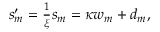Convert formula to latex. <formula><loc_0><loc_0><loc_500><loc_500>\begin{array} { r } { s _ { m } ^ { \prime } = \frac { 1 } { \xi } s _ { m } = \kappa w _ { m } + d _ { m } , } \end{array}</formula> 